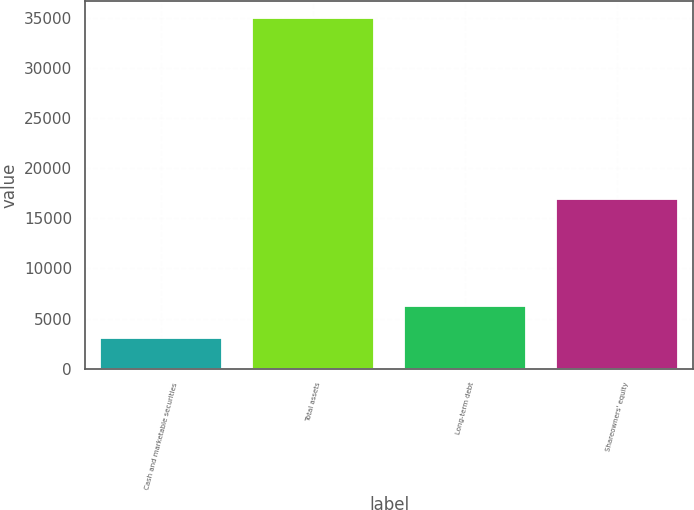Convert chart to OTSL. <chart><loc_0><loc_0><loc_500><loc_500><bar_chart><fcel>Cash and marketable securities<fcel>Total assets<fcel>Long-term debt<fcel>Shareowners' equity<nl><fcel>3041<fcel>34947<fcel>6231.6<fcel>16884<nl></chart> 